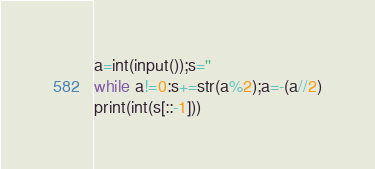Convert code to text. <code><loc_0><loc_0><loc_500><loc_500><_Python_>a=int(input());s=''
while a!=0:s+=str(a%2);a=-(a//2)
print(int(s[::-1]))</code> 